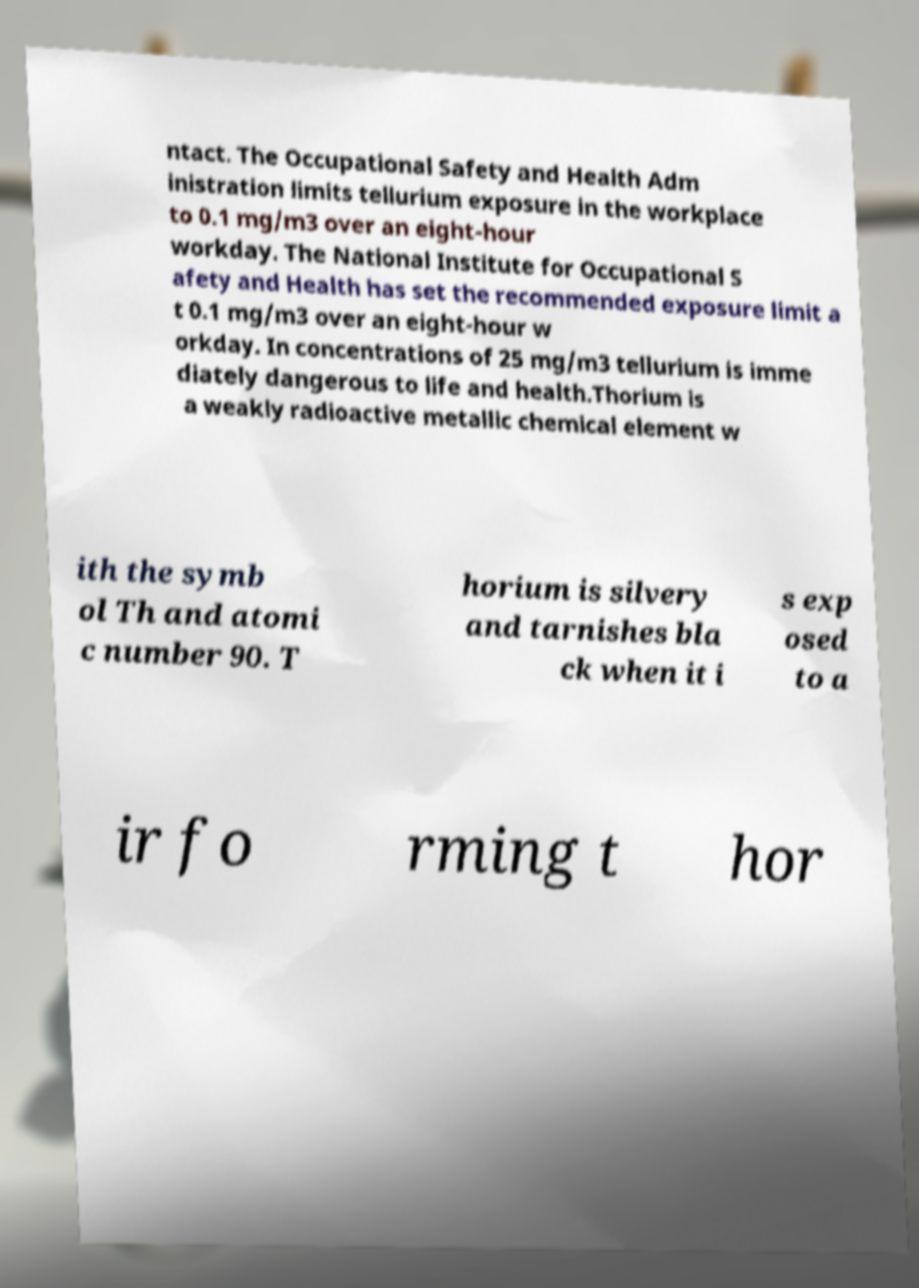What messages or text are displayed in this image? I need them in a readable, typed format. ntact. The Occupational Safety and Health Adm inistration limits tellurium exposure in the workplace to 0.1 mg/m3 over an eight-hour workday. The National Institute for Occupational S afety and Health has set the recommended exposure limit a t 0.1 mg/m3 over an eight-hour w orkday. In concentrations of 25 mg/m3 tellurium is imme diately dangerous to life and health.Thorium is a weakly radioactive metallic chemical element w ith the symb ol Th and atomi c number 90. T horium is silvery and tarnishes bla ck when it i s exp osed to a ir fo rming t hor 